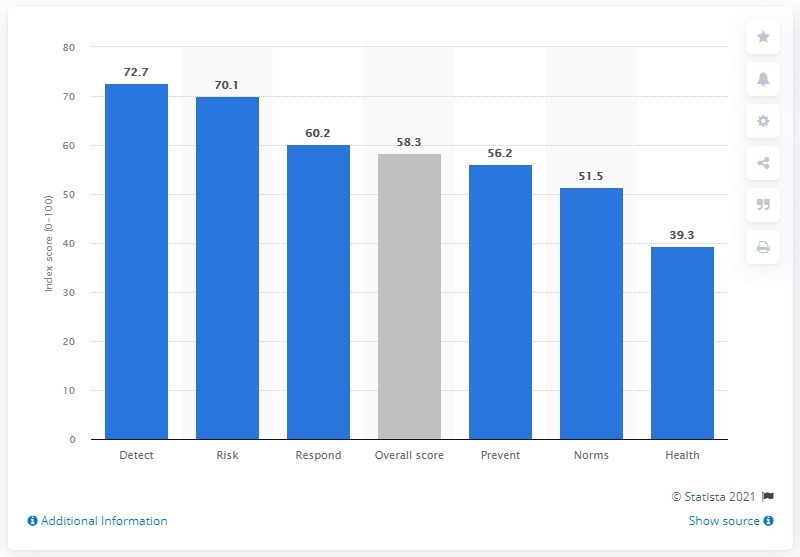Point out several critical features in this image. Chile's health security index score in 2019 was 39.3, indicating a moderate level of health security for the country. Chile's overall health security index score in 2019 was 58.3, indicating a moderate level of health security. 